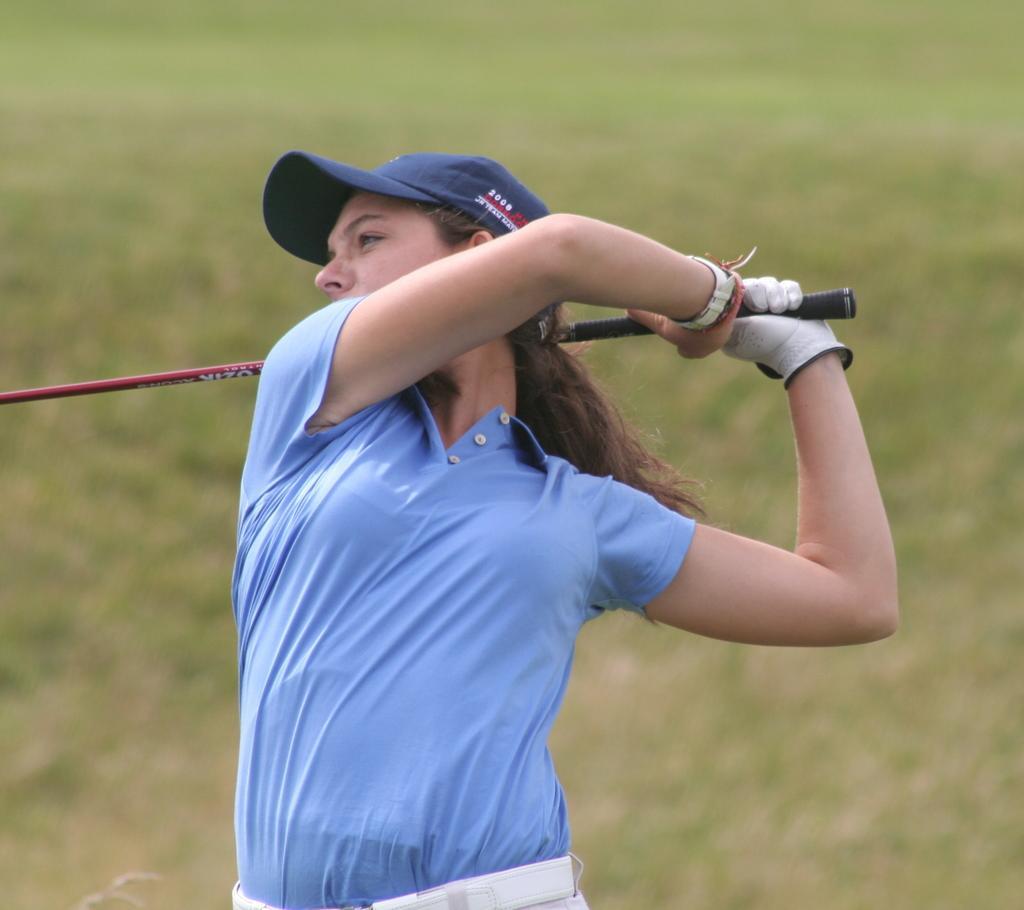Could you give a brief overview of what you see in this image? In this image, we can see a woman standing and she is holding a stick, in the background we can see grass on the ground. 